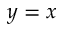Convert formula to latex. <formula><loc_0><loc_0><loc_500><loc_500>y = x</formula> 